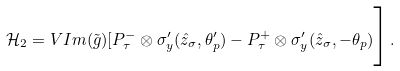<formula> <loc_0><loc_0><loc_500><loc_500>\mathcal { H } _ { 2 } = V I m ( \tilde { g } ) [ P ^ { - } _ { \tau } \otimes \sigma ^ { \prime } _ { y } ( \hat { z } _ { \sigma } , \theta _ { p } ^ { \prime } ) - P ^ { + } _ { \tau } \otimes \sigma ^ { \prime } _ { y } ( \hat { z } _ { \sigma } , - \theta _ { p } ) \Big ] .</formula> 